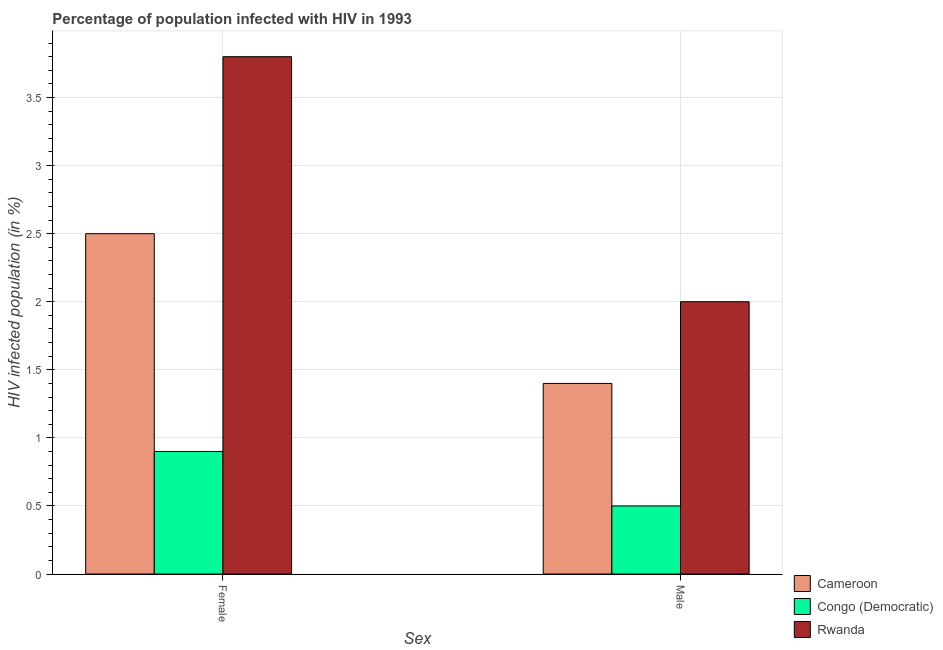How many groups of bars are there?
Offer a very short reply. 2. Are the number of bars per tick equal to the number of legend labels?
Provide a succinct answer. Yes. Are the number of bars on each tick of the X-axis equal?
Your answer should be compact. Yes. How many bars are there on the 2nd tick from the left?
Keep it short and to the point. 3. What is the label of the 1st group of bars from the left?
Offer a terse response. Female. Across all countries, what is the maximum percentage of males who are infected with hiv?
Your response must be concise. 2. In which country was the percentage of females who are infected with hiv maximum?
Your answer should be very brief. Rwanda. In which country was the percentage of males who are infected with hiv minimum?
Keep it short and to the point. Congo (Democratic). What is the total percentage of males who are infected with hiv in the graph?
Ensure brevity in your answer.  3.9. What is the difference between the percentage of males who are infected with hiv in Rwanda and that in Cameroon?
Your response must be concise. 0.6. What is the average percentage of males who are infected with hiv per country?
Offer a terse response. 1.3. In how many countries, is the percentage of males who are infected with hiv greater than 3.6 %?
Your answer should be compact. 0. What is the ratio of the percentage of males who are infected with hiv in Congo (Democratic) to that in Cameroon?
Provide a short and direct response. 0.36. Is the percentage of females who are infected with hiv in Congo (Democratic) less than that in Cameroon?
Give a very brief answer. Yes. What does the 1st bar from the left in Female represents?
Give a very brief answer. Cameroon. What does the 3rd bar from the right in Male represents?
Make the answer very short. Cameroon. Are the values on the major ticks of Y-axis written in scientific E-notation?
Offer a very short reply. No. Where does the legend appear in the graph?
Your answer should be very brief. Bottom right. How many legend labels are there?
Provide a short and direct response. 3. How are the legend labels stacked?
Keep it short and to the point. Vertical. What is the title of the graph?
Provide a short and direct response. Percentage of population infected with HIV in 1993. What is the label or title of the X-axis?
Your response must be concise. Sex. What is the label or title of the Y-axis?
Provide a short and direct response. HIV infected population (in %). What is the HIV infected population (in %) of Cameroon in Female?
Keep it short and to the point. 2.5. What is the HIV infected population (in %) in Cameroon in Male?
Your response must be concise. 1.4. What is the HIV infected population (in %) of Rwanda in Male?
Your answer should be compact. 2. Across all Sex, what is the minimum HIV infected population (in %) in Cameroon?
Your answer should be compact. 1.4. What is the total HIV infected population (in %) in Rwanda in the graph?
Ensure brevity in your answer.  5.8. What is the difference between the HIV infected population (in %) of Cameroon in Female and that in Male?
Offer a very short reply. 1.1. What is the difference between the HIV infected population (in %) of Congo (Democratic) in Female and that in Male?
Your answer should be very brief. 0.4. What is the difference between the HIV infected population (in %) in Cameroon in Female and the HIV infected population (in %) in Rwanda in Male?
Give a very brief answer. 0.5. What is the average HIV infected population (in %) of Cameroon per Sex?
Offer a very short reply. 1.95. What is the average HIV infected population (in %) in Congo (Democratic) per Sex?
Provide a succinct answer. 0.7. What is the difference between the HIV infected population (in %) in Cameroon and HIV infected population (in %) in Congo (Democratic) in Male?
Keep it short and to the point. 0.9. What is the difference between the HIV infected population (in %) in Cameroon and HIV infected population (in %) in Rwanda in Male?
Keep it short and to the point. -0.6. What is the ratio of the HIV infected population (in %) of Cameroon in Female to that in Male?
Your answer should be compact. 1.79. What is the difference between the highest and the lowest HIV infected population (in %) of Cameroon?
Make the answer very short. 1.1. What is the difference between the highest and the lowest HIV infected population (in %) in Congo (Democratic)?
Make the answer very short. 0.4. 